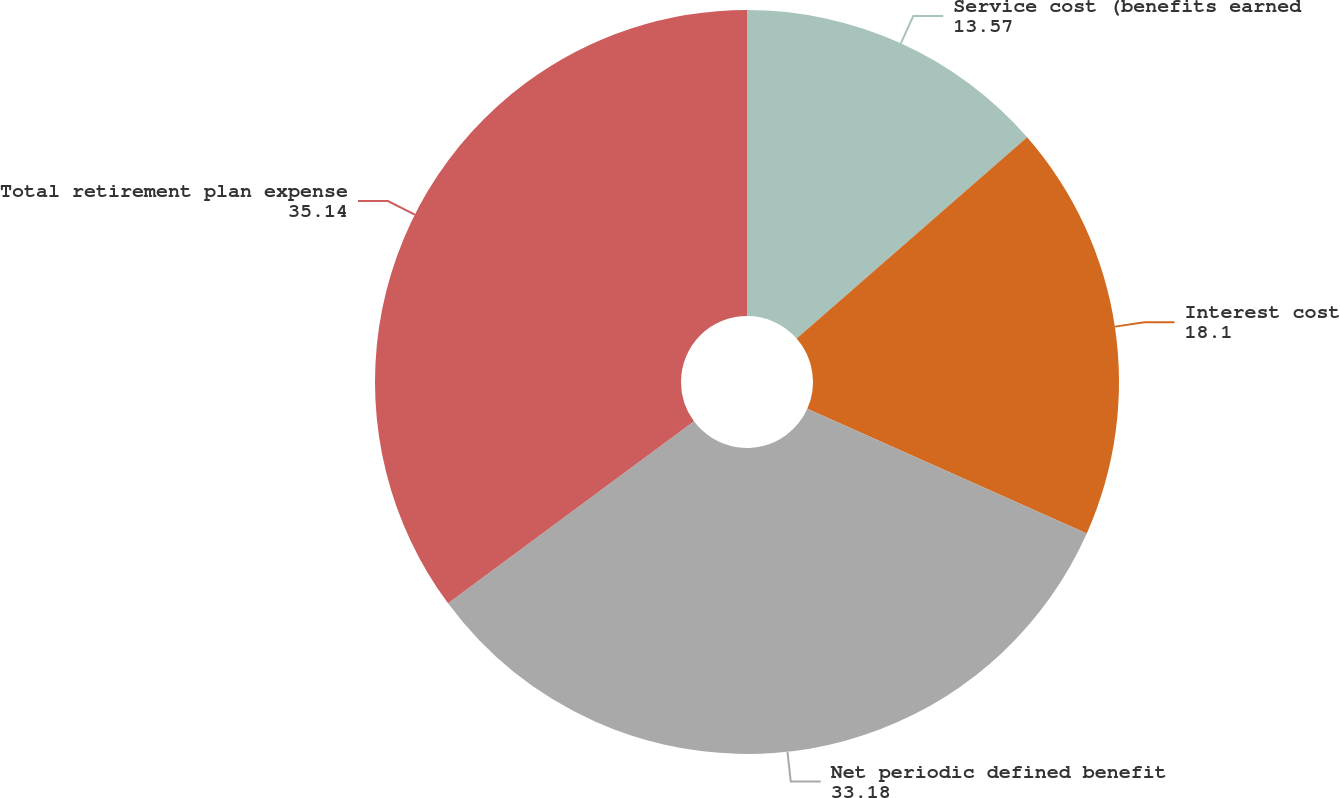<chart> <loc_0><loc_0><loc_500><loc_500><pie_chart><fcel>Service cost (benefits earned<fcel>Interest cost<fcel>Net periodic defined benefit<fcel>Total retirement plan expense<nl><fcel>13.57%<fcel>18.1%<fcel>33.18%<fcel>35.14%<nl></chart> 